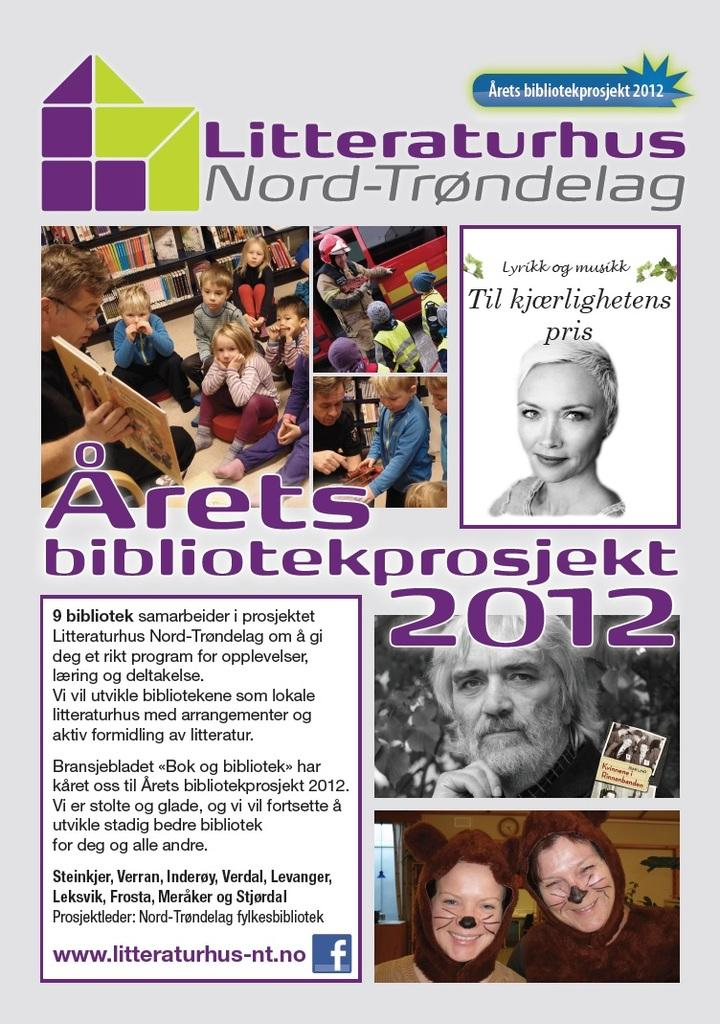What is the main object in the image? There is a poster in the image. What can be seen on the poster? There are people depicted on the poster, and there is text on the poster. Where is the rabbit hiding in the image? There is no rabbit present in the image. What type of bird can be seen flying in the image? There is no bird present in the image. 